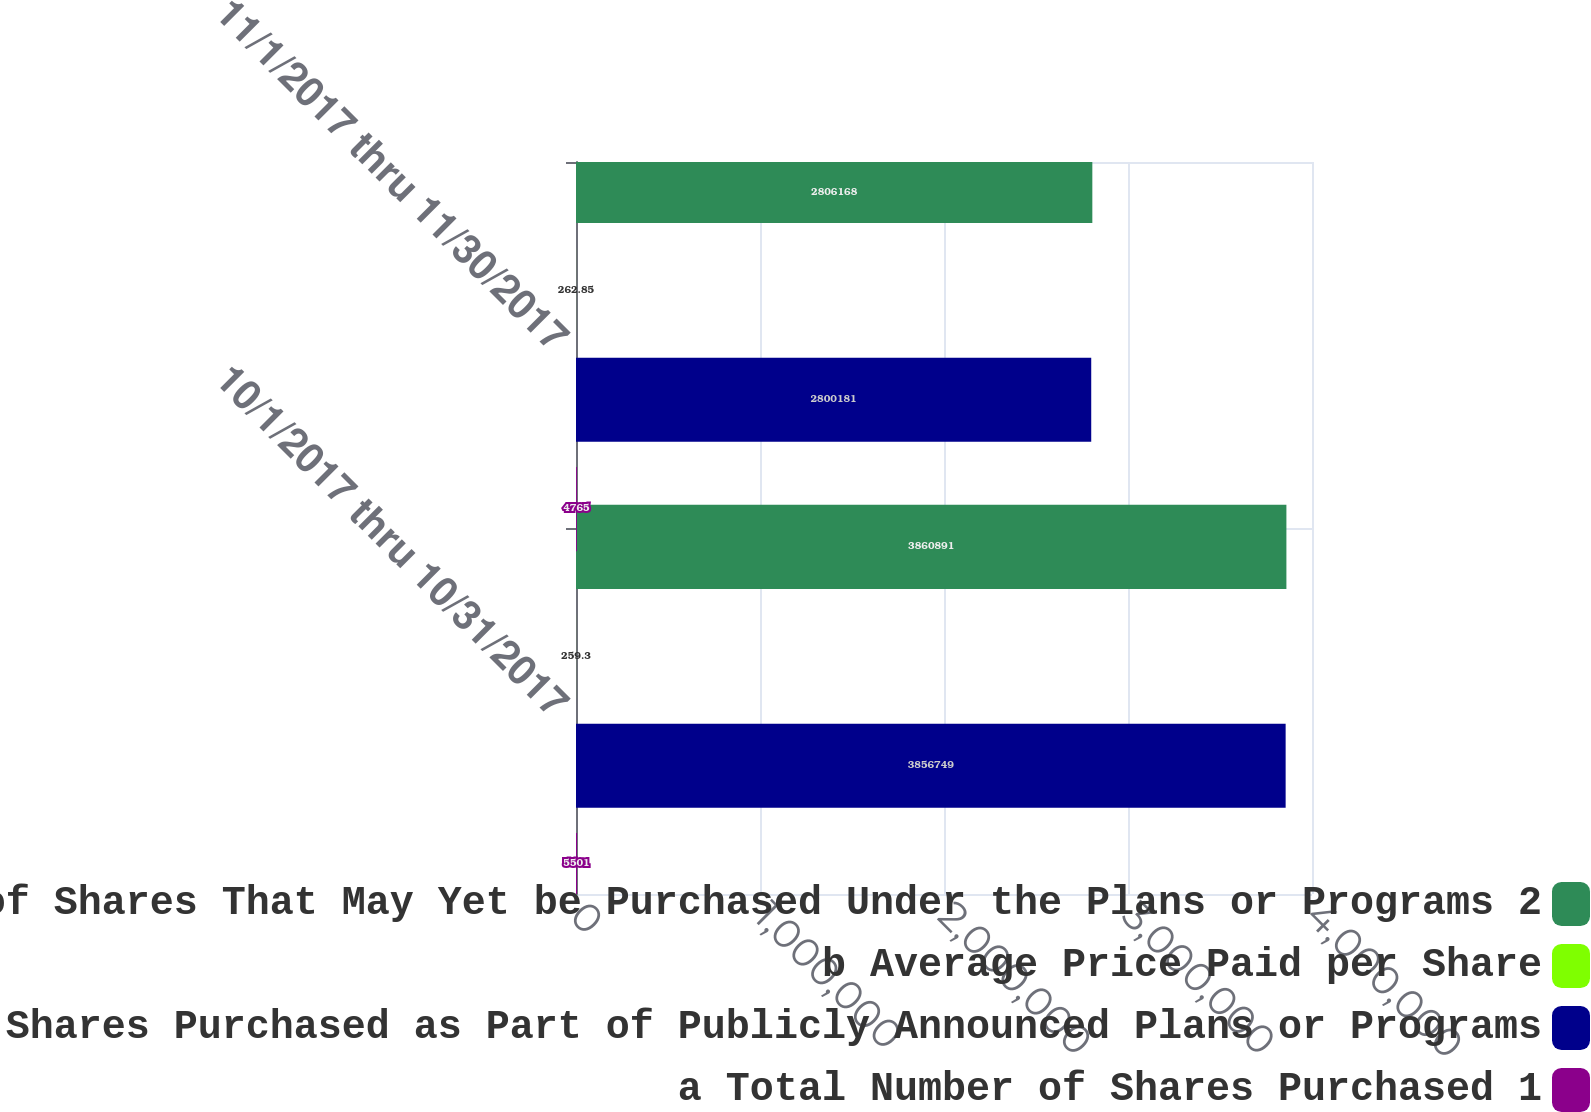<chart> <loc_0><loc_0><loc_500><loc_500><stacked_bar_chart><ecel><fcel>10/1/2017 thru 10/31/2017<fcel>11/1/2017 thru 11/30/2017<nl><fcel>d Approximate Dollar Value of Shares That May Yet be Purchased Under the Plans or Programs 2<fcel>3.86089e+06<fcel>2.80617e+06<nl><fcel>b Average Price Paid per Share<fcel>259.3<fcel>262.85<nl><fcel>c Total Number of Shares Purchased as Part of Publicly Announced Plans or Programs<fcel>3.85675e+06<fcel>2.80018e+06<nl><fcel>a Total Number of Shares Purchased 1<fcel>5501<fcel>4765<nl></chart> 